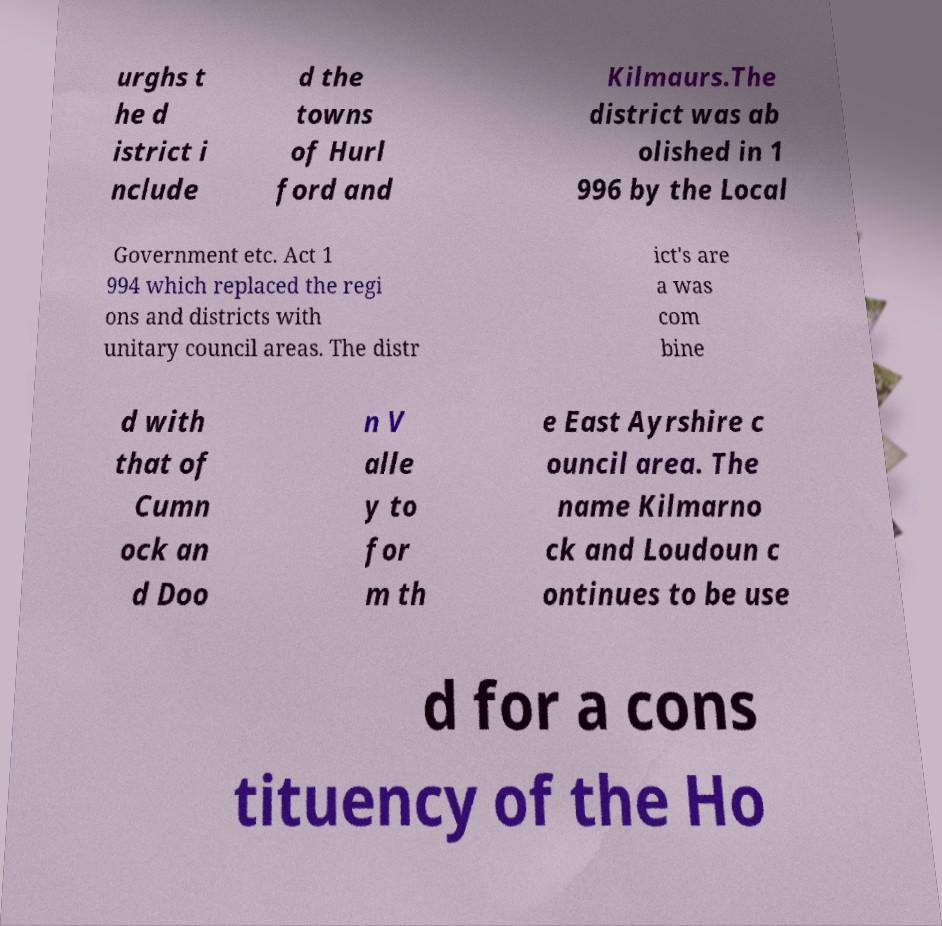There's text embedded in this image that I need extracted. Can you transcribe it verbatim? urghs t he d istrict i nclude d the towns of Hurl ford and Kilmaurs.The district was ab olished in 1 996 by the Local Government etc. Act 1 994 which replaced the regi ons and districts with unitary council areas. The distr ict's are a was com bine d with that of Cumn ock an d Doo n V alle y to for m th e East Ayrshire c ouncil area. The name Kilmarno ck and Loudoun c ontinues to be use d for a cons tituency of the Ho 